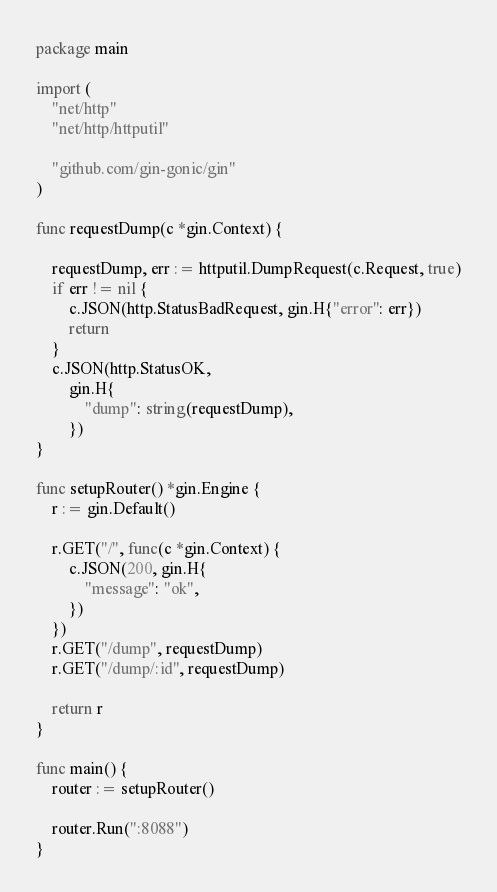Convert code to text. <code><loc_0><loc_0><loc_500><loc_500><_Go_>package main

import (
	"net/http"
	"net/http/httputil"

	"github.com/gin-gonic/gin"
)

func requestDump(c *gin.Context) {

	requestDump, err := httputil.DumpRequest(c.Request, true)
	if err != nil {
		c.JSON(http.StatusBadRequest, gin.H{"error": err})
		return
	}
	c.JSON(http.StatusOK,
		gin.H{
			"dump": string(requestDump),
		})
}

func setupRouter() *gin.Engine {
	r := gin.Default()

	r.GET("/", func(c *gin.Context) {
		c.JSON(200, gin.H{
			"message": "ok",
		})
	})
	r.GET("/dump", requestDump)
	r.GET("/dump/:id", requestDump)

	return r
}

func main() {
	router := setupRouter()

	router.Run(":8088")
}
</code> 